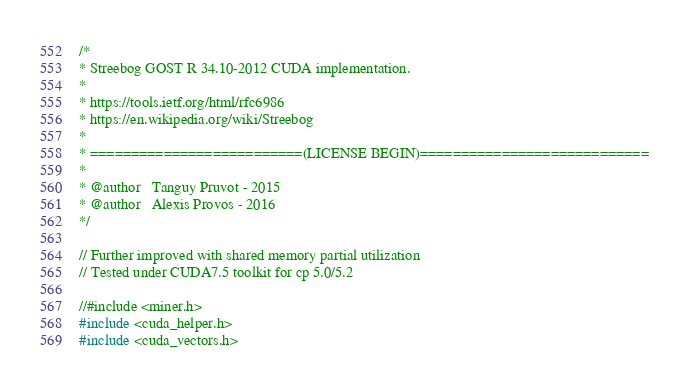<code> <loc_0><loc_0><loc_500><loc_500><_Cuda_>/*
* Streebog GOST R 34.10-2012 CUDA implementation.
*
* https://tools.ietf.org/html/rfc6986
* https://en.wikipedia.org/wiki/Streebog
*
* ==========================(LICENSE BEGIN)============================
*
* @author   Tanguy Pruvot - 2015
* @author   Alexis Provos - 2016
*/

// Further improved with shared memory partial utilization
// Tested under CUDA7.5 toolkit for cp 5.0/5.2

//#include <miner.h>
#include <cuda_helper.h>
#include <cuda_vectors.h>
</code> 